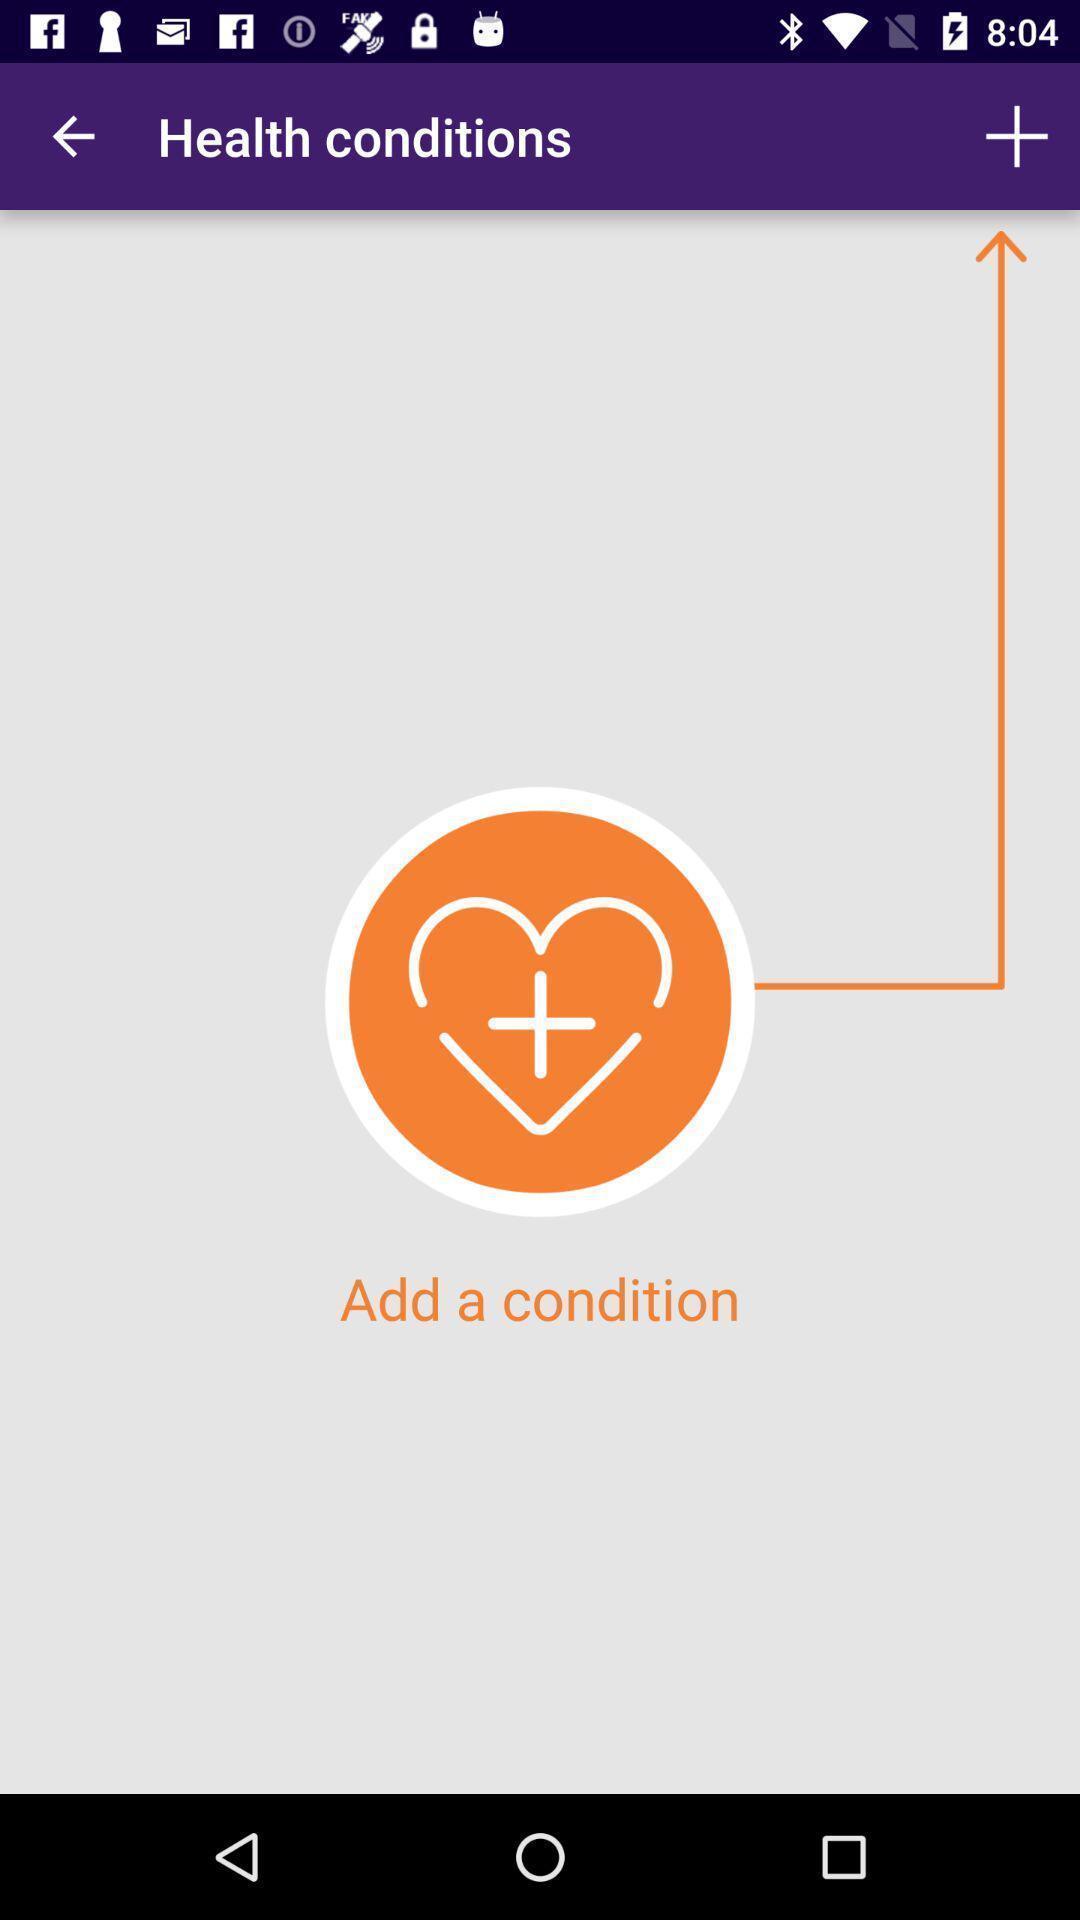What can you discern from this picture? Screen displaying the page of a health app. 